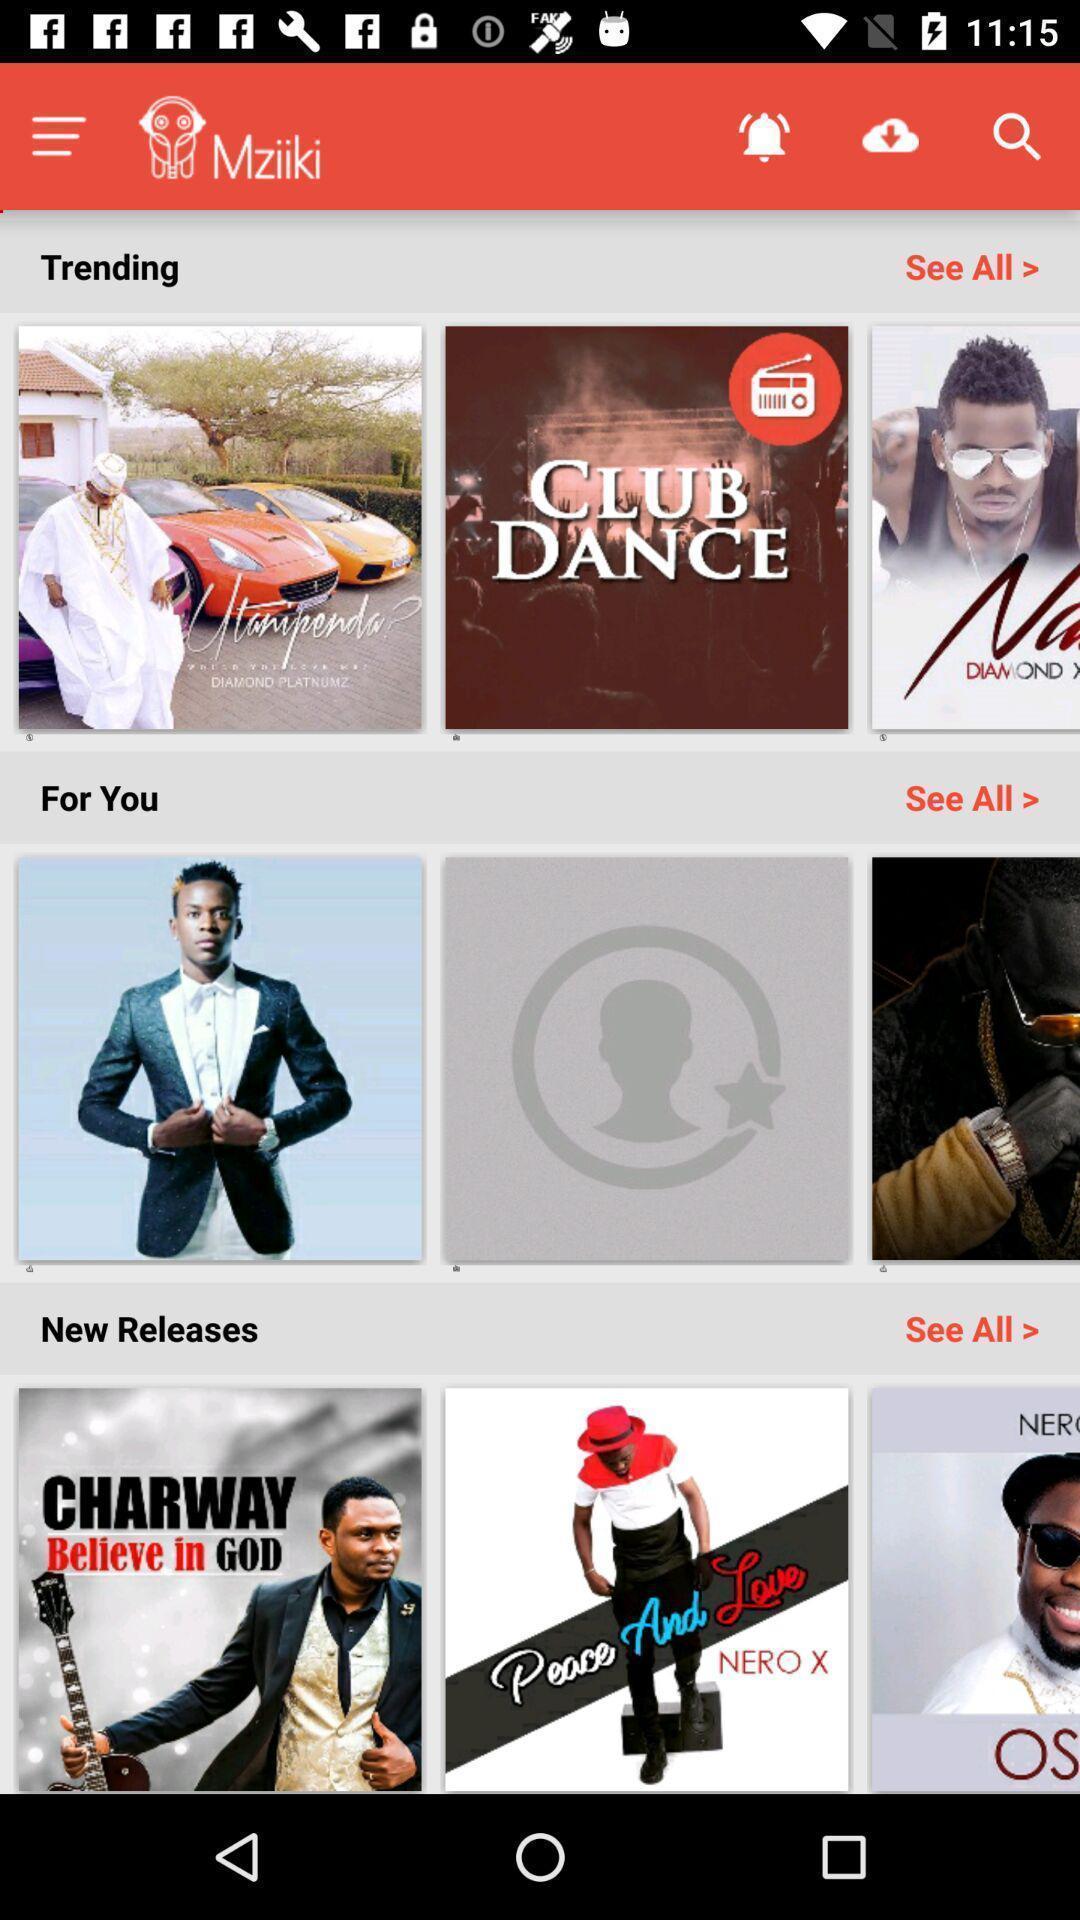Provide a detailed account of this screenshot. Page showing different songs in music. 